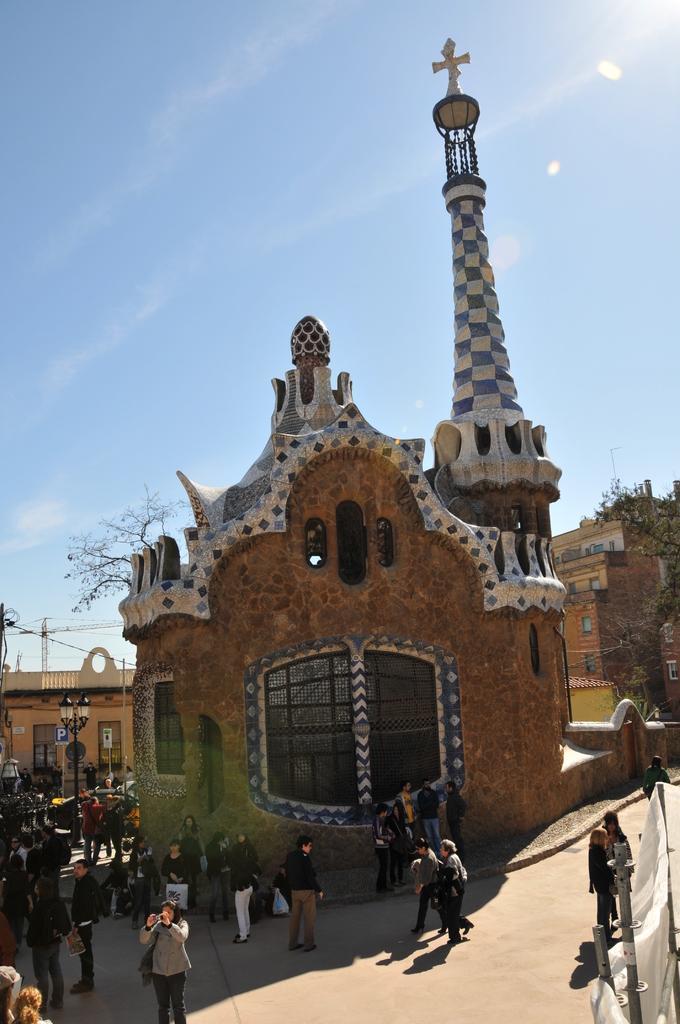Please provide a concise description of this image. In this image we can see people, poles, cloth, boards, buildings, and trees. In the background there is sky. 